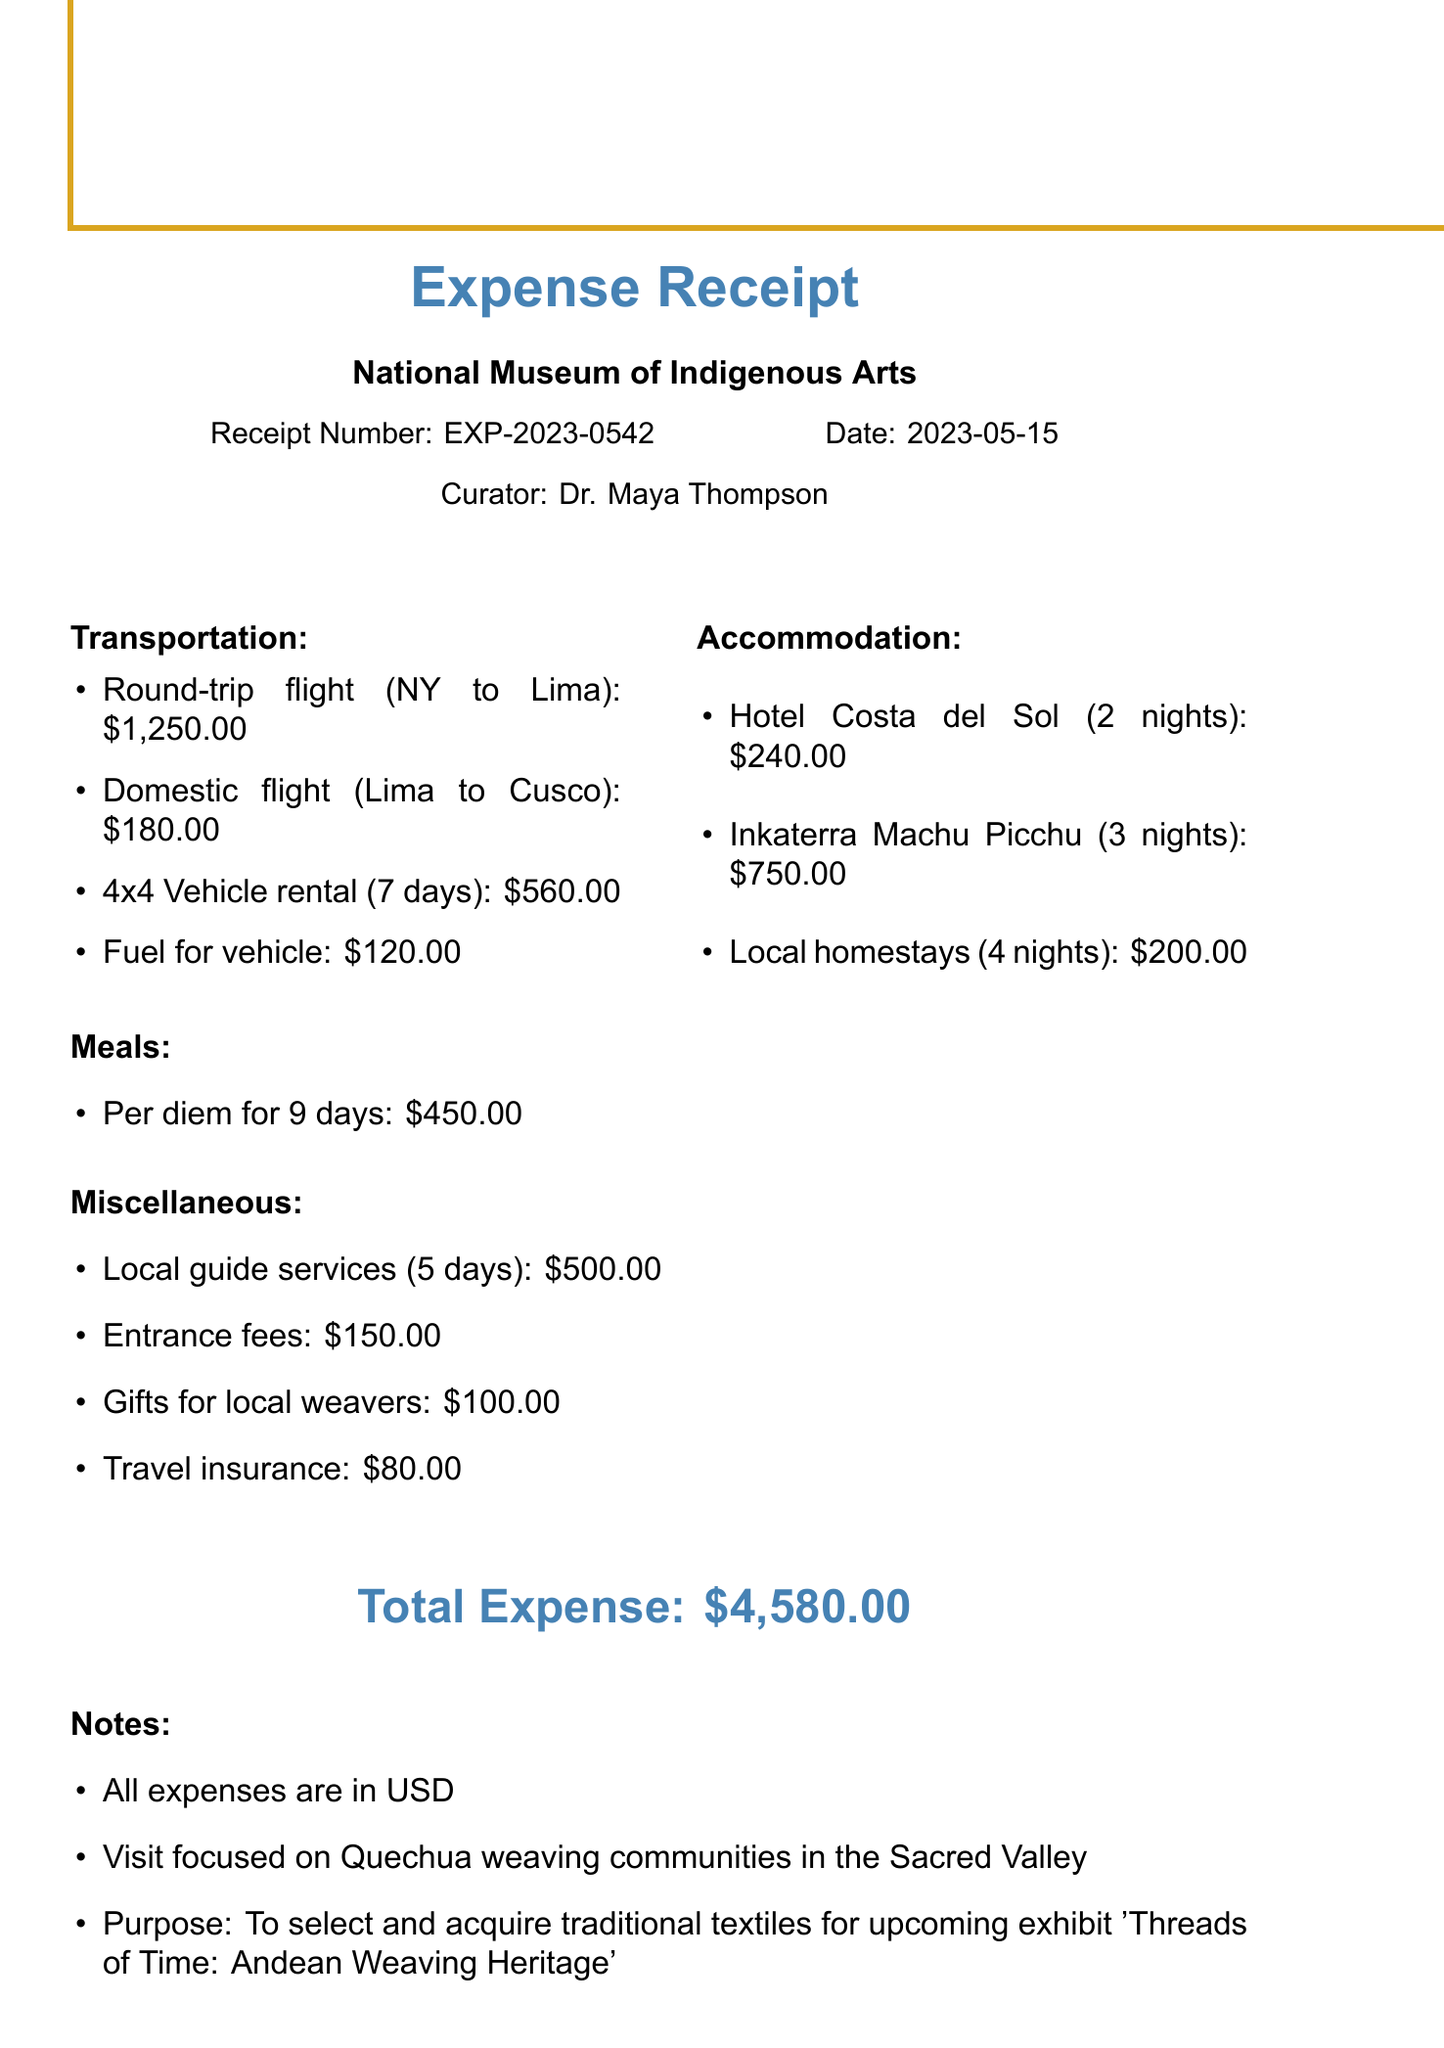What is the receipt number? The receipt number is explicitly stated in the document under "Receipt Number."
Answer: EXP-2023-0542 Who is the curator? The curator's name is mentioned at the top of the document under "Curator."
Answer: Dr. Maya Thompson What is the total expense? The total expense is listed in the document at the bottom, summarizing all costs.
Answer: $4,580.00 How many nights did the curator stay at Inkaterra Machu Picchu Pueblo Hotel? The number of nights at the hotel is stated in the accommodation section.
Answer: 3 nights What was the purpose of the visit? The document includes a note explaining the purpose of the trip.
Answer: To select and acquire traditional textiles for upcoming exhibit 'Threads of Time: Andean Weaving Heritage' What transportation costs are included? Transportation costs are listed in the specific category, detailing the expenses incurred.
Answer: Round-trip flight, domestic flight, vehicle rental, fuel How much was spent on gifts for local weavers? This information is found in the miscellaneous section of the document.
Answer: $100.00 Which airline was used for the round-trip flight? The airline is specified next to the flight description in the transportation section.
Answer: LATAM Airlines How many days of local guide services were paid for? The duration of the local guide services is mentioned under miscellaneous expenses.
Answer: 5 days 